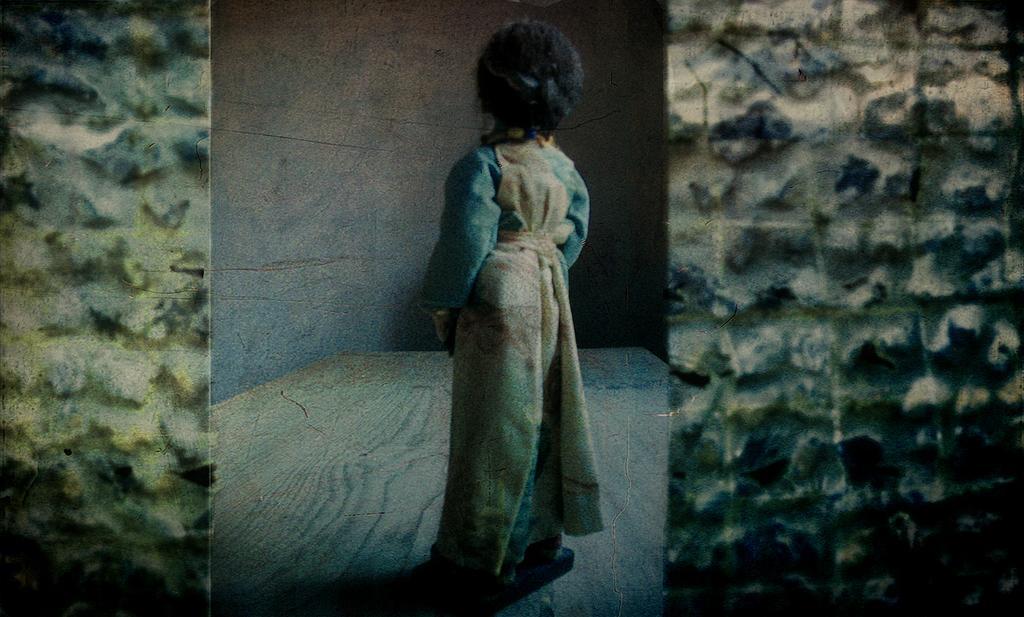Could you give a brief overview of what you see in this image? In this image I can see a person's status on the floor and wall. This image is taken may be in a hall. 